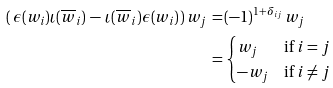<formula> <loc_0><loc_0><loc_500><loc_500>( \, \epsilon ( w _ { i } ) \iota ( \overline { w } _ { i } ) \, - \, \iota ( \overline { w } _ { i } ) \epsilon ( w _ { i } ) \, ) \, w _ { j } \, = \, & ( - 1 ) ^ { 1 + \delta _ { i j } } \, w _ { j } \\ = \, & \begin{cases} w _ { j } & \text {if $i=j$} \\ - w _ { j } & \text {if $i \neq j$} \end{cases}</formula> 